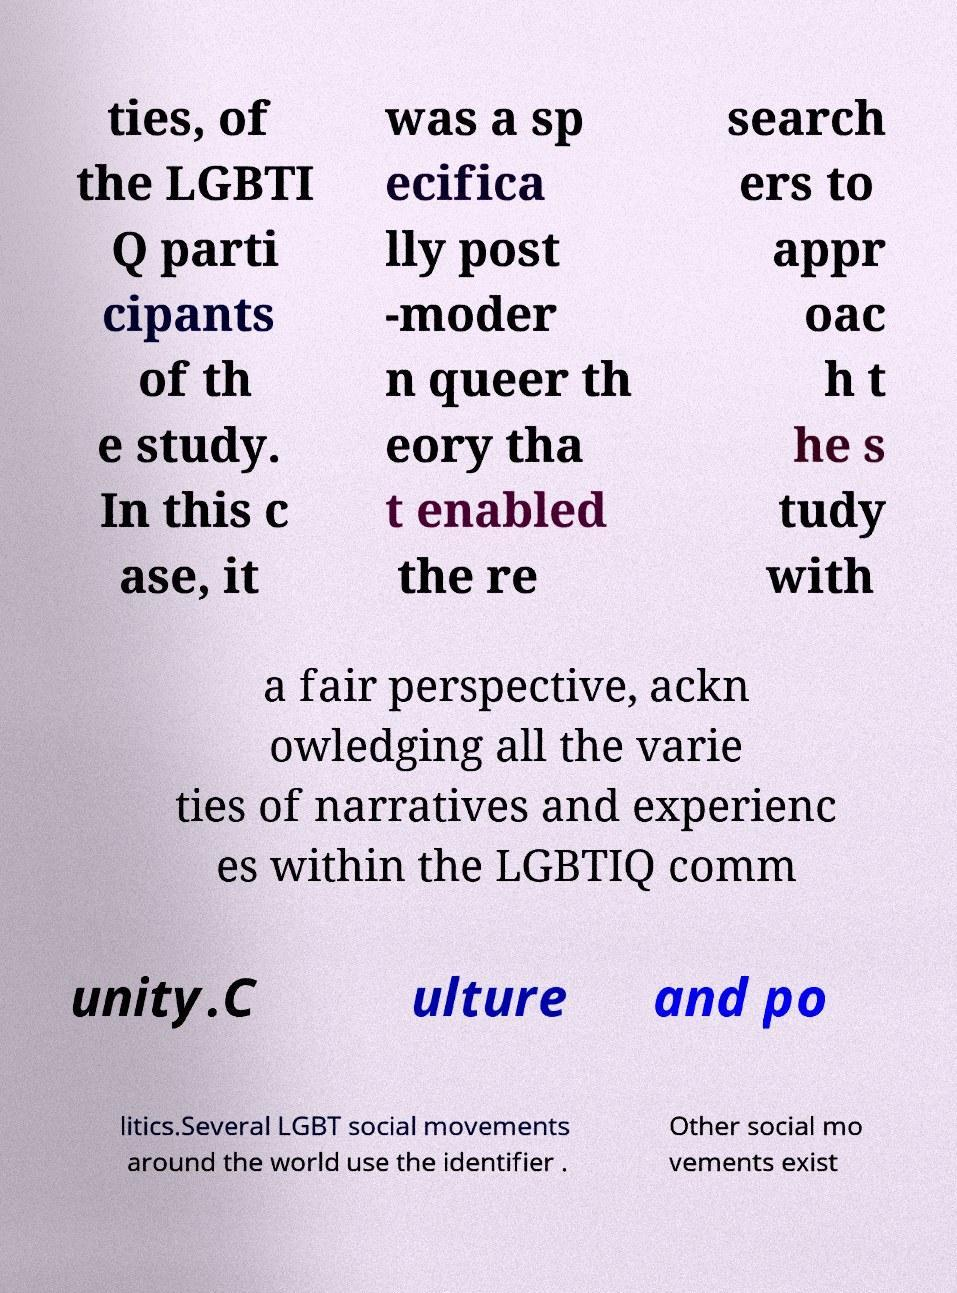Please identify and transcribe the text found in this image. ties, of the LGBTI Q parti cipants of th e study. In this c ase, it was a sp ecifica lly post -moder n queer th eory tha t enabled the re search ers to appr oac h t he s tudy with a fair perspective, ackn owledging all the varie ties of narratives and experienc es within the LGBTIQ comm unity.C ulture and po litics.Several LGBT social movements around the world use the identifier . Other social mo vements exist 